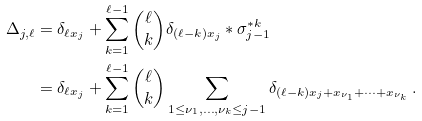<formula> <loc_0><loc_0><loc_500><loc_500>\Delta _ { j , \ell } & = \delta _ { \ell x _ { j } } + \sum _ { k = 1 } ^ { \ell - 1 } \binom { \ell } { k } \delta _ { ( \ell - k ) x _ { j } } * \sigma _ { j - 1 } ^ { * k } \, \\ & = \delta _ { \ell x _ { j } } + \sum _ { k = 1 } ^ { \ell - 1 } \binom { \ell } { k } \sum _ { 1 \leq \nu _ { 1 } , \dots , \nu _ { k } \leq j - 1 } \delta _ { ( \ell - k ) x _ { j } + x _ { \nu _ { 1 } } + \dots + x _ { \nu _ { k } } } \, .</formula> 